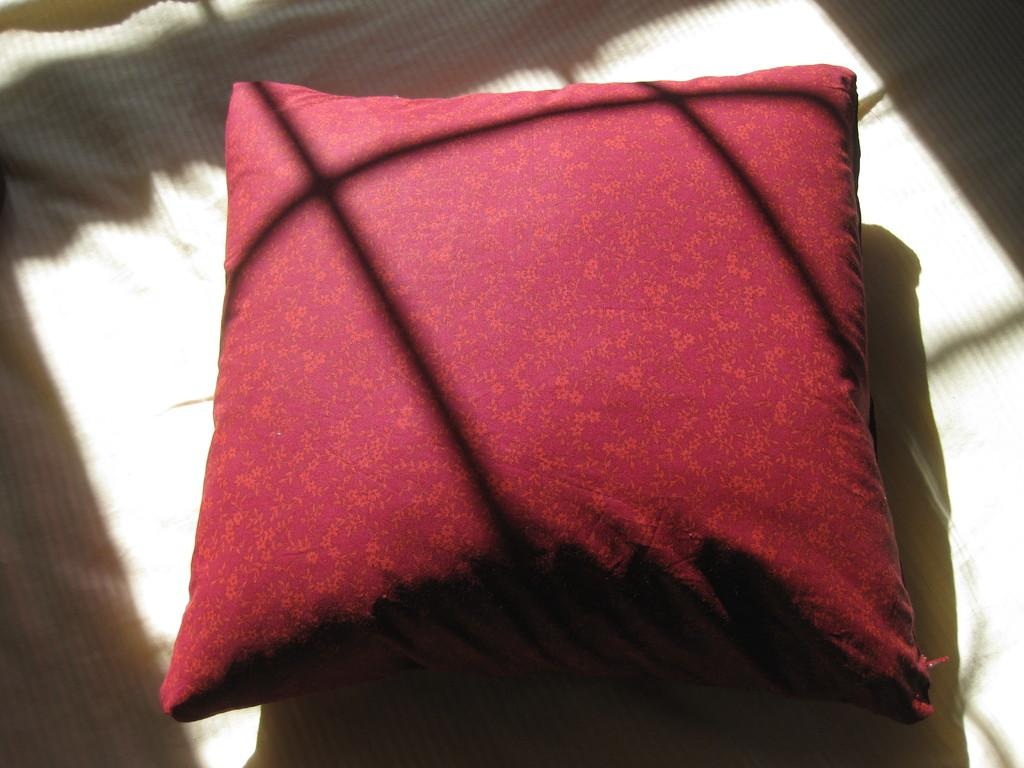What is the color of the pillow in the image? The pillow in the image is red. What is the pillow placed on in the image? The pillow is on a white color bed sheet. Can you see the cloth used to make the cap in the image? There is no cap present in the image, so it is not possible to see the cloth used to make it. 